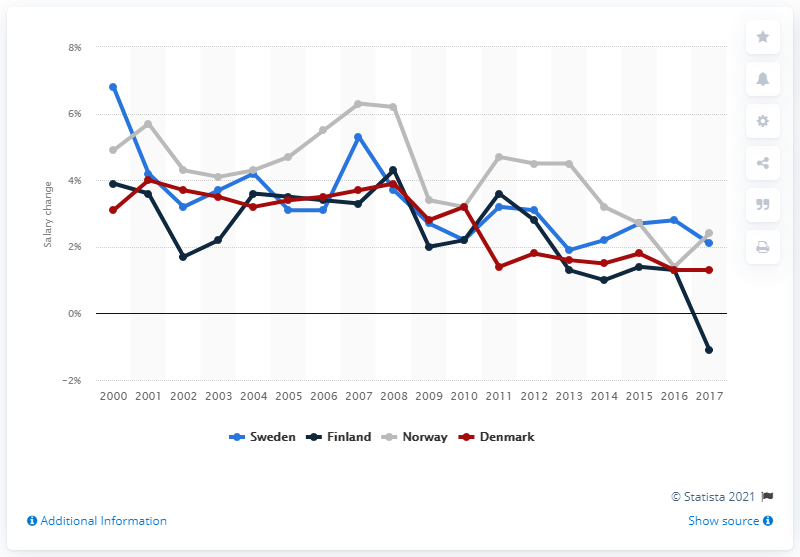Point out several critical features in this image. The country with the highest salary growth in 2017 was Norway. In 2017, the wages in Denmark and Sweden experienced significant growth, with an increase of 1.3%. In 2008, the average salaries in Finland increased by 4.3%. In 2000, the annual salary growth in Sweden was 6.8%. 